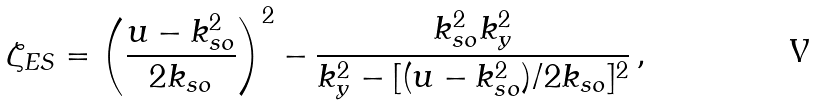<formula> <loc_0><loc_0><loc_500><loc_500>\zeta _ { E S } = \left ( \frac { u - k _ { s o } ^ { 2 } } { 2 k _ { s o } } \right ) ^ { 2 } - \frac { k _ { s o } ^ { 2 } k _ { y } ^ { 2 } } { k _ { y } ^ { 2 } - [ ( u - k _ { s o } ^ { 2 } ) / 2 k _ { s o } ] ^ { 2 } } \, ,</formula> 